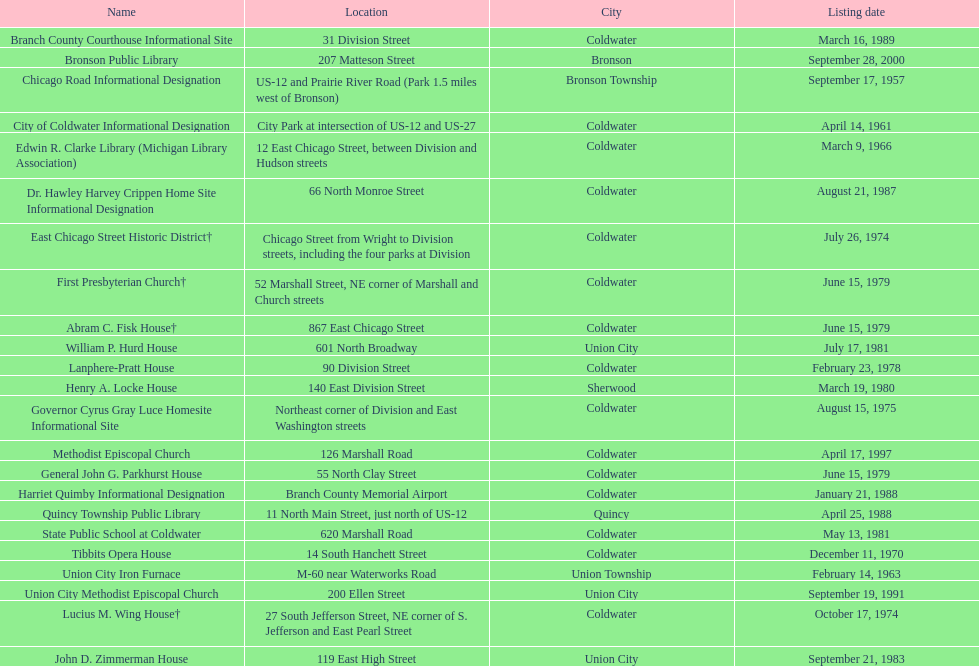In which city are the most historic places located? Coldwater. 